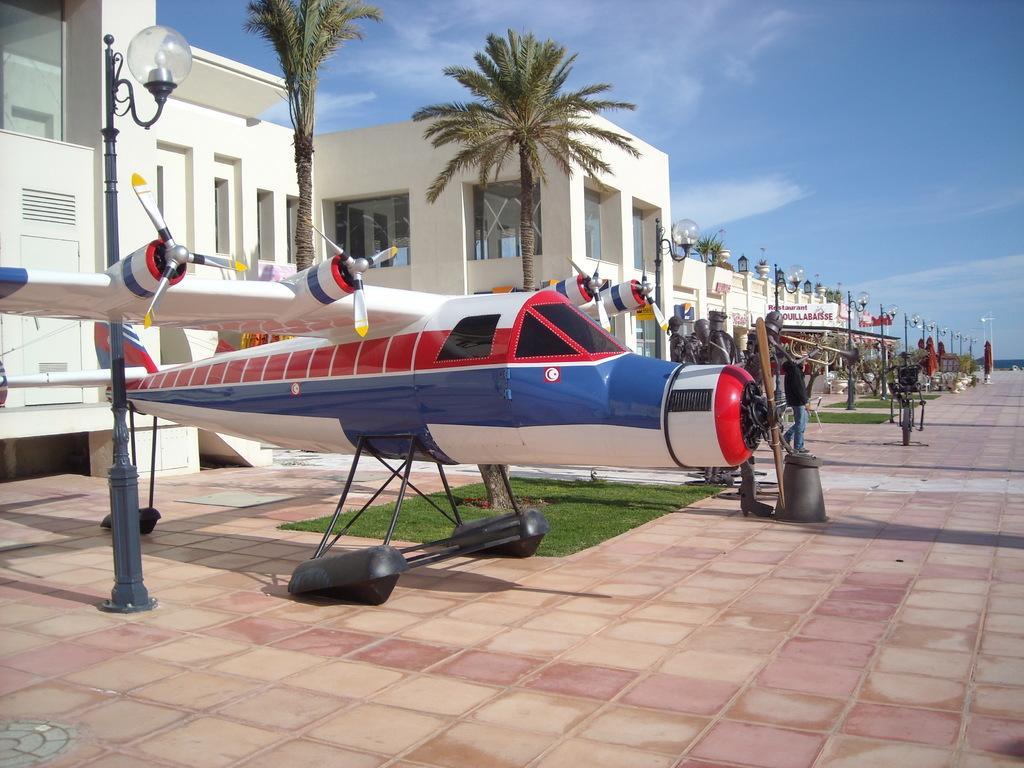Describe this image in one or two sentences. In this image I can see an aircraft, trees, light poles, buildings, sky, grass, people and objects. 